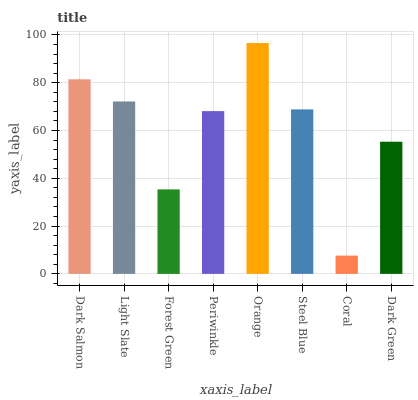Is Coral the minimum?
Answer yes or no. Yes. Is Orange the maximum?
Answer yes or no. Yes. Is Light Slate the minimum?
Answer yes or no. No. Is Light Slate the maximum?
Answer yes or no. No. Is Dark Salmon greater than Light Slate?
Answer yes or no. Yes. Is Light Slate less than Dark Salmon?
Answer yes or no. Yes. Is Light Slate greater than Dark Salmon?
Answer yes or no. No. Is Dark Salmon less than Light Slate?
Answer yes or no. No. Is Steel Blue the high median?
Answer yes or no. Yes. Is Periwinkle the low median?
Answer yes or no. Yes. Is Coral the high median?
Answer yes or no. No. Is Light Slate the low median?
Answer yes or no. No. 